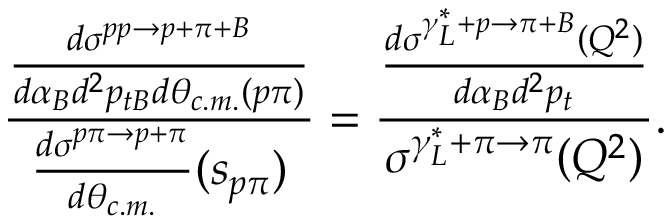Convert formula to latex. <formula><loc_0><loc_0><loc_500><loc_500>{ \frac { \frac { d \sigma ^ { p p \to p + \pi + B } } { d \alpha _ { B } d ^ { 2 } p _ { t B } d \theta _ { c . m . } ( p \pi ) } } { { \frac { d \sigma ^ { p \pi \to p + \pi } } { d \theta _ { c . m . } } } ( s _ { p \pi } ) } } = { \frac { \frac { d \sigma ^ { \gamma _ { L } ^ { * } + p \to \pi + B } ( Q ^ { 2 } ) } { d \alpha _ { B } d ^ { 2 } p _ { t } } } { \sigma ^ { \gamma _ { L } ^ { * } + \pi \to \pi } ( Q ^ { 2 } ) } } .</formula> 